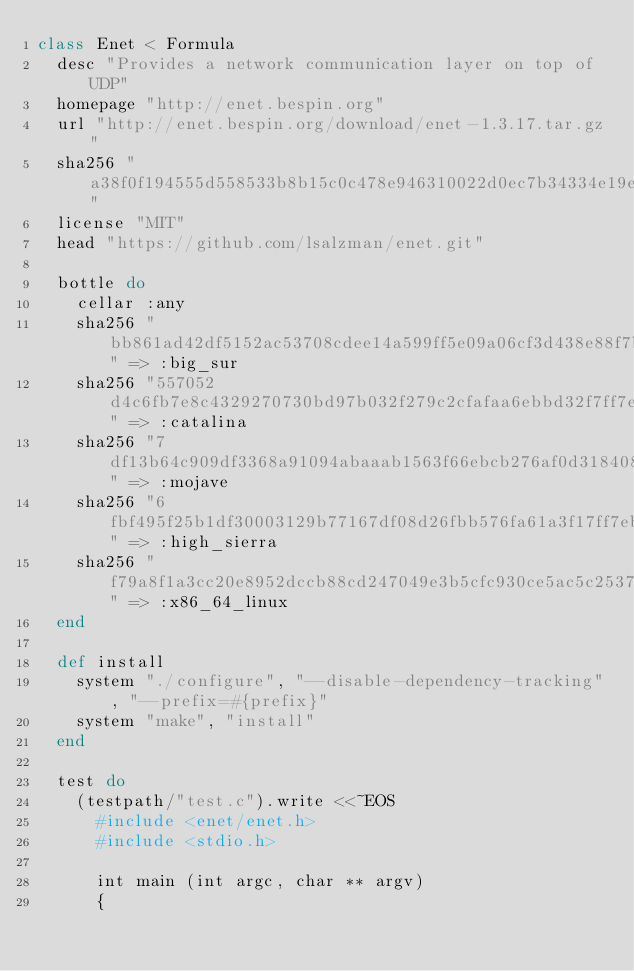Convert code to text. <code><loc_0><loc_0><loc_500><loc_500><_Ruby_>class Enet < Formula
  desc "Provides a network communication layer on top of UDP"
  homepage "http://enet.bespin.org"
  url "http://enet.bespin.org/download/enet-1.3.17.tar.gz"
  sha256 "a38f0f194555d558533b8b15c0c478e946310022d0ec7b34334e19e4574dcedc"
  license "MIT"
  head "https://github.com/lsalzman/enet.git"

  bottle do
    cellar :any
    sha256 "bb861ad42df5152ac53708cdee14a599ff5e09a06cf3d438e88f7bc6b84590db" => :big_sur
    sha256 "557052d4c6fb7e8c4329270730bd97b032f279c2cfafaa6ebbd32f7ff7e076bf" => :catalina
    sha256 "7df13b64c909df3368a91094abaaab1563f66ebcb276af0d318408977af08d2f" => :mojave
    sha256 "6fbf495f25b1df30003129b77167df08d26fbb576fa61a3f17ff7eba366bdd2a" => :high_sierra
    sha256 "f79a8f1a3cc20e8952dccb88cd247049e3b5cfc930ce5ac5c2537e386df051d8" => :x86_64_linux
  end

  def install
    system "./configure", "--disable-dependency-tracking", "--prefix=#{prefix}"
    system "make", "install"
  end

  test do
    (testpath/"test.c").write <<~EOS
      #include <enet/enet.h>
      #include <stdio.h>

      int main (int argc, char ** argv)
      {</code> 